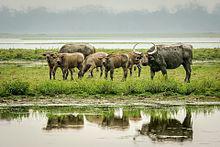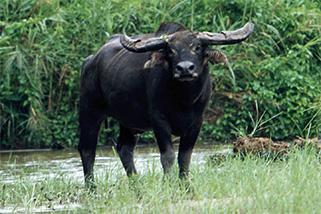The first image is the image on the left, the second image is the image on the right. Given the left and right images, does the statement "A water buffalo is standing on a body of water." hold true? Answer yes or no. No. 